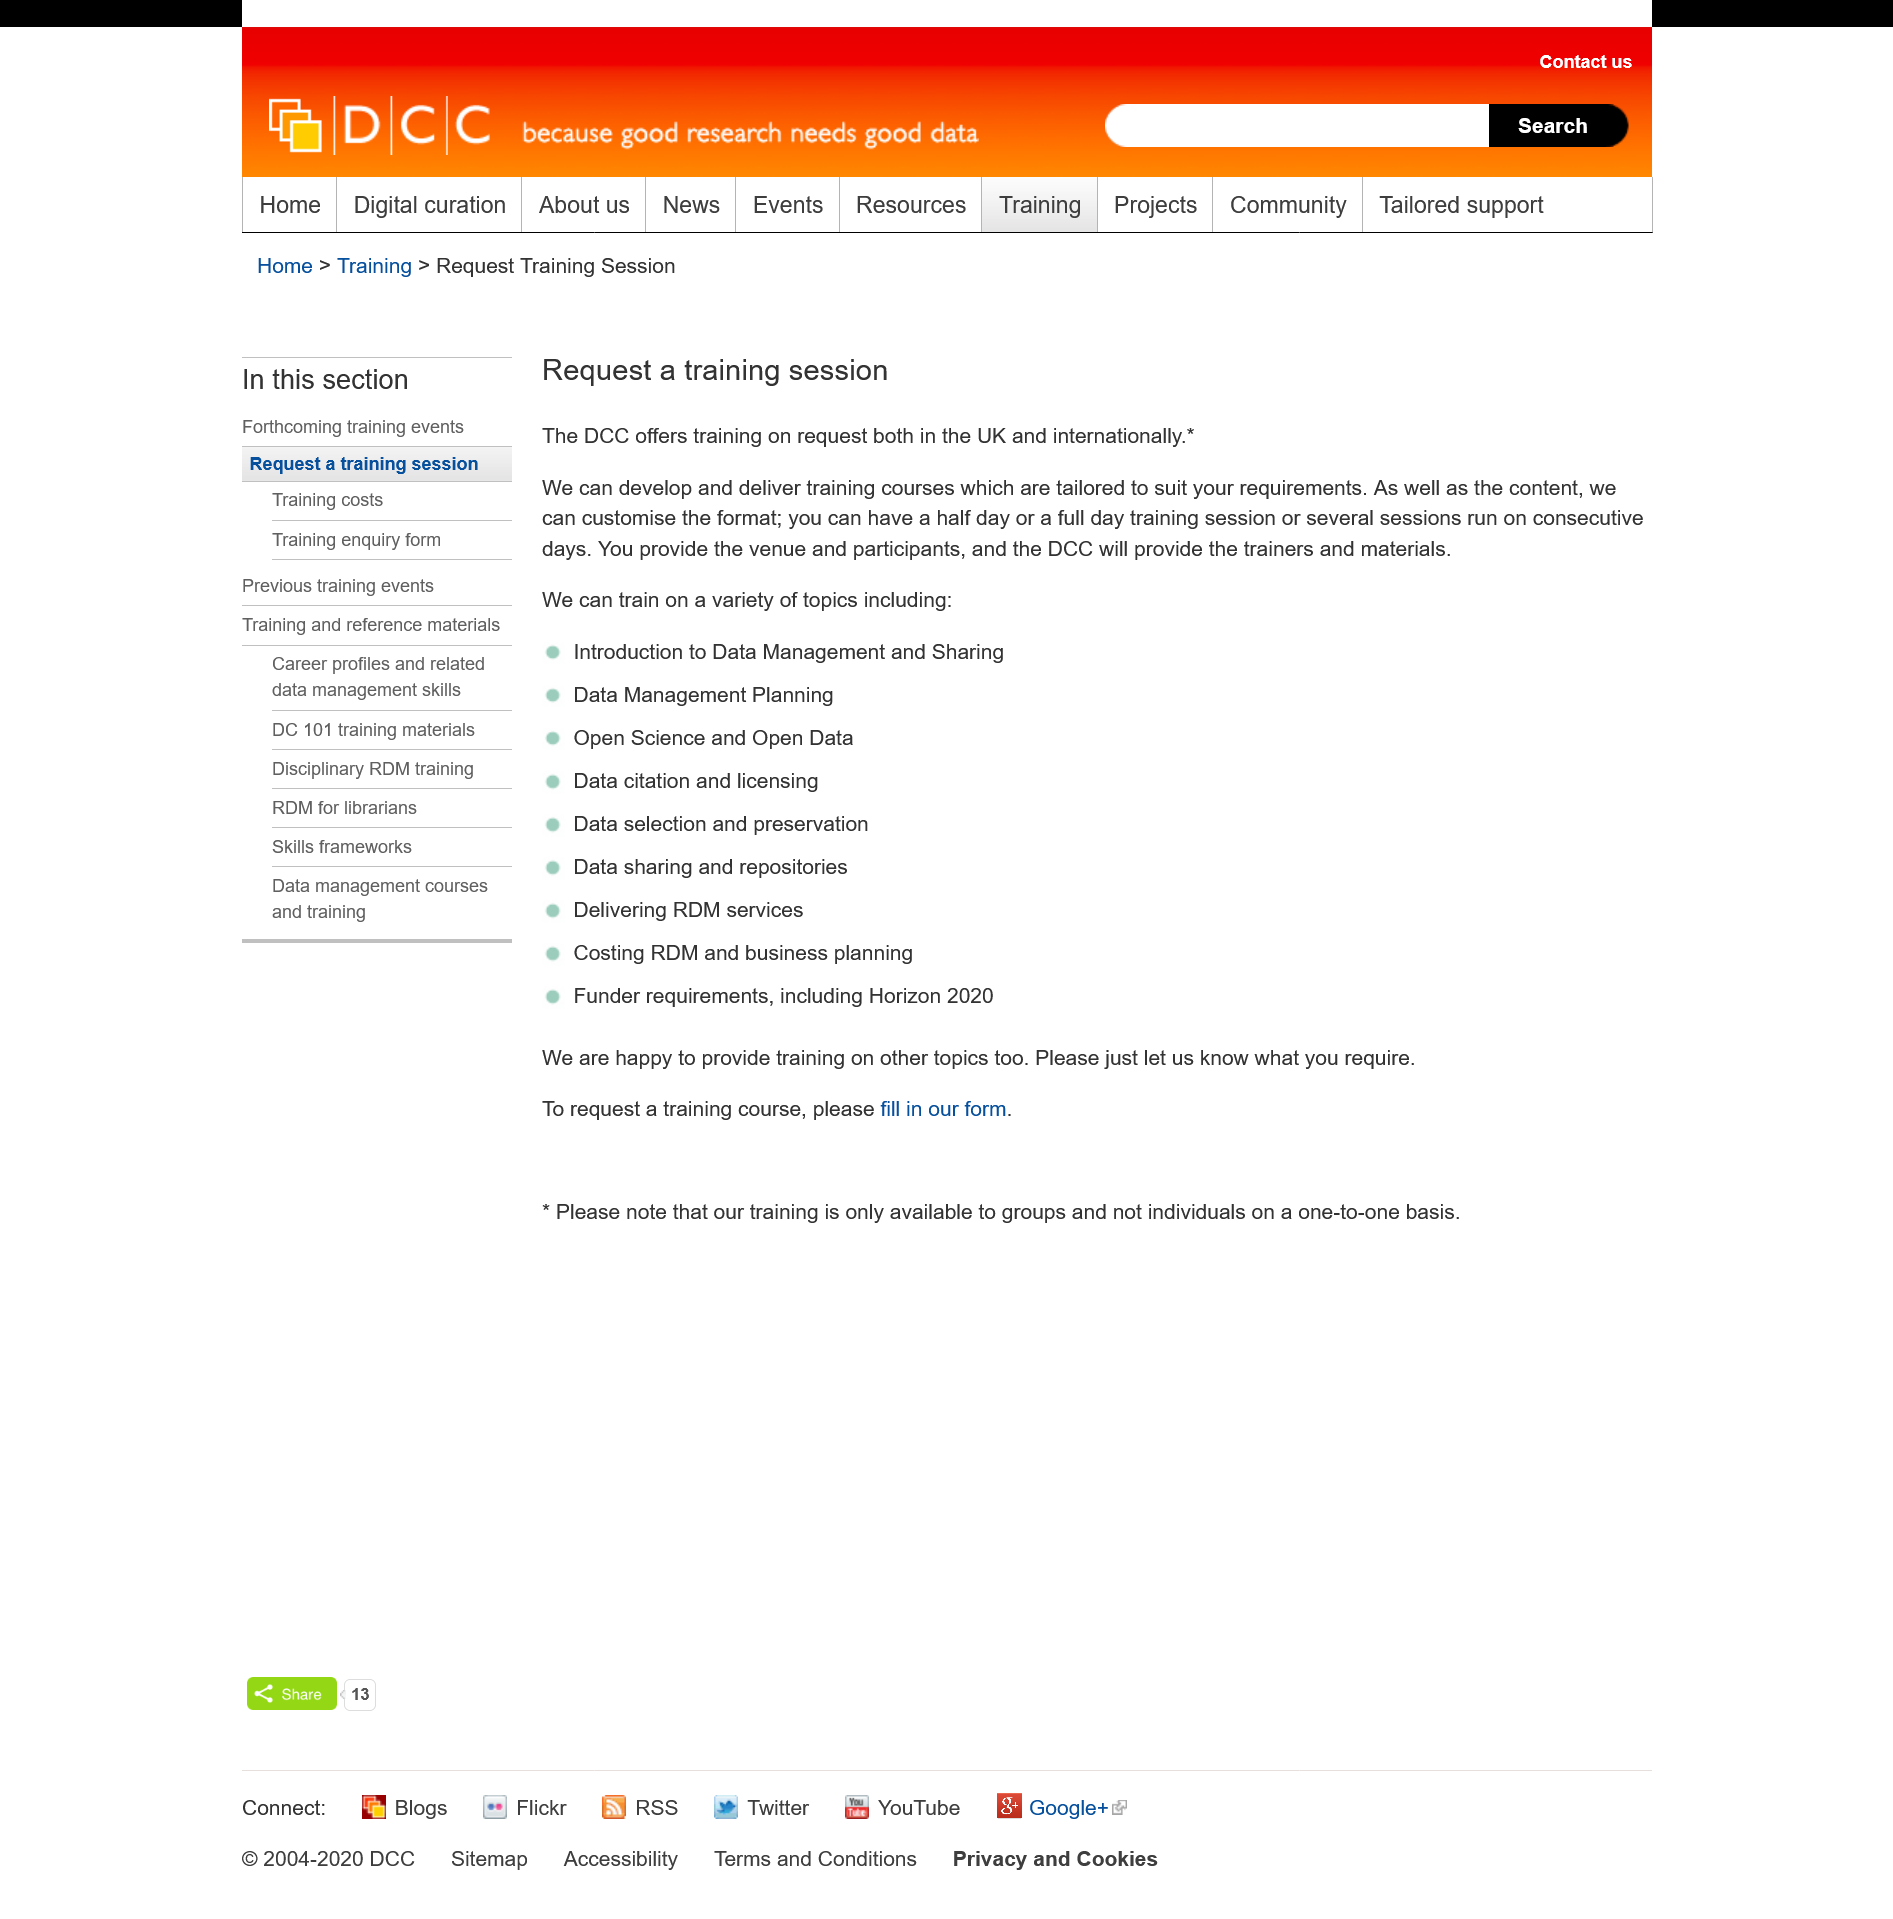Draw attention to some important aspects in this diagram. The title of this page is 'request a training session'. This page is dedicated to requesting a training session. It is not necessary for you to be located in the United Kingdom in order to request a training session. 